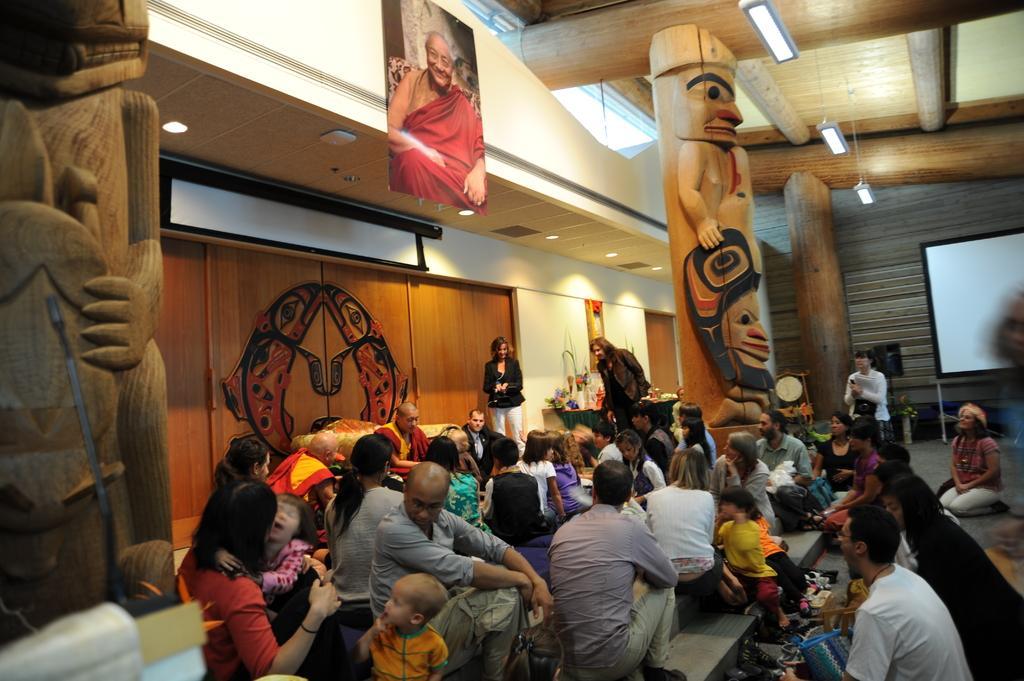How would you summarize this image in a sentence or two? In the picture I can see a group of people sitting on the staircase. I can see a man sitting on the sofa. There is a screen on the right side. I can see a photo frame at the top of the picture. I can see the design wooden pillars. There is a lighting arrangement on the roof. 